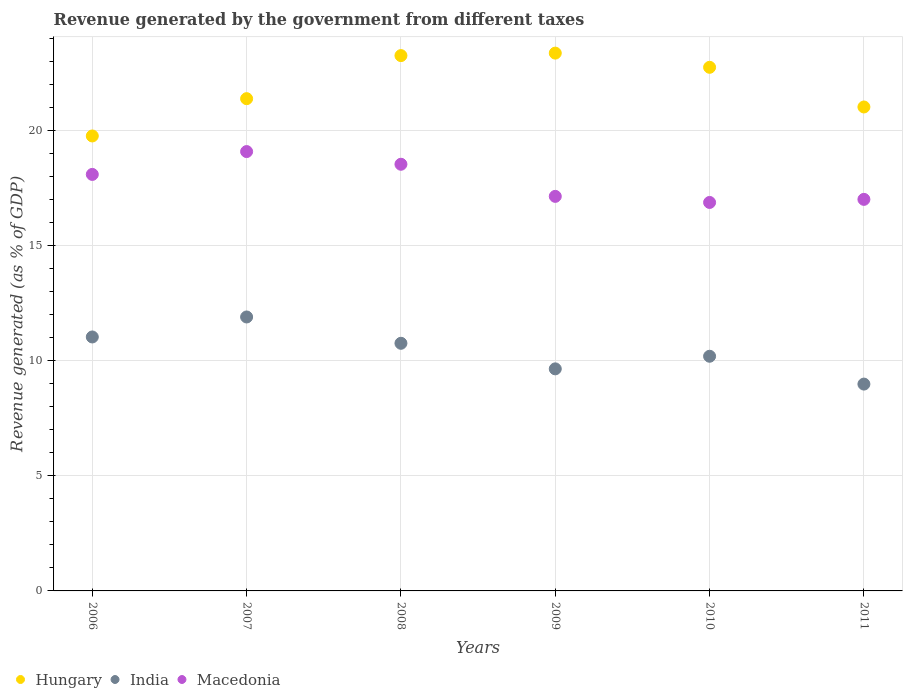How many different coloured dotlines are there?
Ensure brevity in your answer.  3. Is the number of dotlines equal to the number of legend labels?
Your answer should be very brief. Yes. What is the revenue generated by the government in Hungary in 2009?
Offer a very short reply. 23.35. Across all years, what is the maximum revenue generated by the government in Macedonia?
Provide a succinct answer. 19.07. Across all years, what is the minimum revenue generated by the government in Macedonia?
Ensure brevity in your answer.  16.87. What is the total revenue generated by the government in Macedonia in the graph?
Ensure brevity in your answer.  106.68. What is the difference between the revenue generated by the government in India in 2007 and that in 2011?
Provide a short and direct response. 2.91. What is the difference between the revenue generated by the government in Macedonia in 2011 and the revenue generated by the government in India in 2010?
Give a very brief answer. 6.81. What is the average revenue generated by the government in Hungary per year?
Provide a short and direct response. 21.91. In the year 2007, what is the difference between the revenue generated by the government in India and revenue generated by the government in Macedonia?
Ensure brevity in your answer.  -7.18. In how many years, is the revenue generated by the government in Macedonia greater than 15 %?
Provide a succinct answer. 6. What is the ratio of the revenue generated by the government in Hungary in 2010 to that in 2011?
Provide a short and direct response. 1.08. What is the difference between the highest and the second highest revenue generated by the government in Hungary?
Your answer should be compact. 0.11. What is the difference between the highest and the lowest revenue generated by the government in Hungary?
Your answer should be compact. 3.6. In how many years, is the revenue generated by the government in Macedonia greater than the average revenue generated by the government in Macedonia taken over all years?
Your response must be concise. 3. Is the sum of the revenue generated by the government in India in 2006 and 2010 greater than the maximum revenue generated by the government in Hungary across all years?
Your response must be concise. No. Does the revenue generated by the government in India monotonically increase over the years?
Offer a terse response. No. Is the revenue generated by the government in Hungary strictly less than the revenue generated by the government in India over the years?
Offer a very short reply. No. How many dotlines are there?
Offer a very short reply. 3. How many years are there in the graph?
Your answer should be compact. 6. Are the values on the major ticks of Y-axis written in scientific E-notation?
Offer a terse response. No. Does the graph contain any zero values?
Keep it short and to the point. No. How many legend labels are there?
Ensure brevity in your answer.  3. What is the title of the graph?
Keep it short and to the point. Revenue generated by the government from different taxes. Does "Cameroon" appear as one of the legend labels in the graph?
Offer a terse response. No. What is the label or title of the X-axis?
Your response must be concise. Years. What is the label or title of the Y-axis?
Offer a terse response. Revenue generated (as % of GDP). What is the Revenue generated (as % of GDP) in Hungary in 2006?
Make the answer very short. 19.75. What is the Revenue generated (as % of GDP) in India in 2006?
Ensure brevity in your answer.  11.03. What is the Revenue generated (as % of GDP) in Macedonia in 2006?
Your response must be concise. 18.08. What is the Revenue generated (as % of GDP) in Hungary in 2007?
Your response must be concise. 21.37. What is the Revenue generated (as % of GDP) in India in 2007?
Offer a very short reply. 11.89. What is the Revenue generated (as % of GDP) in Macedonia in 2007?
Give a very brief answer. 19.07. What is the Revenue generated (as % of GDP) of Hungary in 2008?
Your response must be concise. 23.24. What is the Revenue generated (as % of GDP) of India in 2008?
Your answer should be compact. 10.75. What is the Revenue generated (as % of GDP) of Macedonia in 2008?
Provide a short and direct response. 18.52. What is the Revenue generated (as % of GDP) in Hungary in 2009?
Provide a short and direct response. 23.35. What is the Revenue generated (as % of GDP) in India in 2009?
Offer a terse response. 9.64. What is the Revenue generated (as % of GDP) in Macedonia in 2009?
Your answer should be compact. 17.13. What is the Revenue generated (as % of GDP) of Hungary in 2010?
Give a very brief answer. 22.73. What is the Revenue generated (as % of GDP) of India in 2010?
Give a very brief answer. 10.19. What is the Revenue generated (as % of GDP) in Macedonia in 2010?
Offer a terse response. 16.87. What is the Revenue generated (as % of GDP) in Hungary in 2011?
Ensure brevity in your answer.  21.01. What is the Revenue generated (as % of GDP) in India in 2011?
Ensure brevity in your answer.  8.98. What is the Revenue generated (as % of GDP) of Macedonia in 2011?
Make the answer very short. 17. Across all years, what is the maximum Revenue generated (as % of GDP) in Hungary?
Make the answer very short. 23.35. Across all years, what is the maximum Revenue generated (as % of GDP) in India?
Keep it short and to the point. 11.89. Across all years, what is the maximum Revenue generated (as % of GDP) in Macedonia?
Your answer should be compact. 19.07. Across all years, what is the minimum Revenue generated (as % of GDP) in Hungary?
Offer a terse response. 19.75. Across all years, what is the minimum Revenue generated (as % of GDP) of India?
Offer a very short reply. 8.98. Across all years, what is the minimum Revenue generated (as % of GDP) of Macedonia?
Your response must be concise. 16.87. What is the total Revenue generated (as % of GDP) in Hungary in the graph?
Your answer should be compact. 131.46. What is the total Revenue generated (as % of GDP) in India in the graph?
Your response must be concise. 62.48. What is the total Revenue generated (as % of GDP) of Macedonia in the graph?
Make the answer very short. 106.68. What is the difference between the Revenue generated (as % of GDP) in Hungary in 2006 and that in 2007?
Give a very brief answer. -1.62. What is the difference between the Revenue generated (as % of GDP) in India in 2006 and that in 2007?
Keep it short and to the point. -0.87. What is the difference between the Revenue generated (as % of GDP) in Macedonia in 2006 and that in 2007?
Give a very brief answer. -0.99. What is the difference between the Revenue generated (as % of GDP) of Hungary in 2006 and that in 2008?
Your answer should be very brief. -3.49. What is the difference between the Revenue generated (as % of GDP) of India in 2006 and that in 2008?
Provide a succinct answer. 0.27. What is the difference between the Revenue generated (as % of GDP) of Macedonia in 2006 and that in 2008?
Your response must be concise. -0.44. What is the difference between the Revenue generated (as % of GDP) in Hungary in 2006 and that in 2009?
Offer a terse response. -3.6. What is the difference between the Revenue generated (as % of GDP) in India in 2006 and that in 2009?
Your answer should be compact. 1.38. What is the difference between the Revenue generated (as % of GDP) of Macedonia in 2006 and that in 2009?
Give a very brief answer. 0.95. What is the difference between the Revenue generated (as % of GDP) in Hungary in 2006 and that in 2010?
Keep it short and to the point. -2.98. What is the difference between the Revenue generated (as % of GDP) of India in 2006 and that in 2010?
Your response must be concise. 0.84. What is the difference between the Revenue generated (as % of GDP) of Macedonia in 2006 and that in 2010?
Provide a short and direct response. 1.22. What is the difference between the Revenue generated (as % of GDP) of Hungary in 2006 and that in 2011?
Give a very brief answer. -1.26. What is the difference between the Revenue generated (as % of GDP) of India in 2006 and that in 2011?
Your answer should be compact. 2.05. What is the difference between the Revenue generated (as % of GDP) in Macedonia in 2006 and that in 2011?
Make the answer very short. 1.08. What is the difference between the Revenue generated (as % of GDP) of Hungary in 2007 and that in 2008?
Your answer should be very brief. -1.87. What is the difference between the Revenue generated (as % of GDP) in India in 2007 and that in 2008?
Give a very brief answer. 1.14. What is the difference between the Revenue generated (as % of GDP) in Macedonia in 2007 and that in 2008?
Your answer should be very brief. 0.55. What is the difference between the Revenue generated (as % of GDP) of Hungary in 2007 and that in 2009?
Offer a terse response. -1.98. What is the difference between the Revenue generated (as % of GDP) of India in 2007 and that in 2009?
Your response must be concise. 2.25. What is the difference between the Revenue generated (as % of GDP) of Macedonia in 2007 and that in 2009?
Offer a very short reply. 1.95. What is the difference between the Revenue generated (as % of GDP) in Hungary in 2007 and that in 2010?
Give a very brief answer. -1.36. What is the difference between the Revenue generated (as % of GDP) in India in 2007 and that in 2010?
Your response must be concise. 1.71. What is the difference between the Revenue generated (as % of GDP) of Macedonia in 2007 and that in 2010?
Offer a very short reply. 2.21. What is the difference between the Revenue generated (as % of GDP) in Hungary in 2007 and that in 2011?
Your answer should be very brief. 0.36. What is the difference between the Revenue generated (as % of GDP) in India in 2007 and that in 2011?
Your answer should be very brief. 2.91. What is the difference between the Revenue generated (as % of GDP) in Macedonia in 2007 and that in 2011?
Provide a short and direct response. 2.08. What is the difference between the Revenue generated (as % of GDP) of Hungary in 2008 and that in 2009?
Your answer should be very brief. -0.11. What is the difference between the Revenue generated (as % of GDP) in India in 2008 and that in 2009?
Offer a terse response. 1.11. What is the difference between the Revenue generated (as % of GDP) of Macedonia in 2008 and that in 2009?
Your response must be concise. 1.39. What is the difference between the Revenue generated (as % of GDP) of Hungary in 2008 and that in 2010?
Provide a short and direct response. 0.51. What is the difference between the Revenue generated (as % of GDP) of India in 2008 and that in 2010?
Offer a very short reply. 0.56. What is the difference between the Revenue generated (as % of GDP) in Macedonia in 2008 and that in 2010?
Ensure brevity in your answer.  1.66. What is the difference between the Revenue generated (as % of GDP) of Hungary in 2008 and that in 2011?
Your response must be concise. 2.23. What is the difference between the Revenue generated (as % of GDP) of India in 2008 and that in 2011?
Your answer should be compact. 1.77. What is the difference between the Revenue generated (as % of GDP) in Macedonia in 2008 and that in 2011?
Your response must be concise. 1.52. What is the difference between the Revenue generated (as % of GDP) of Hungary in 2009 and that in 2010?
Offer a terse response. 0.62. What is the difference between the Revenue generated (as % of GDP) of India in 2009 and that in 2010?
Ensure brevity in your answer.  -0.55. What is the difference between the Revenue generated (as % of GDP) in Macedonia in 2009 and that in 2010?
Keep it short and to the point. 0.26. What is the difference between the Revenue generated (as % of GDP) in Hungary in 2009 and that in 2011?
Give a very brief answer. 2.34. What is the difference between the Revenue generated (as % of GDP) in India in 2009 and that in 2011?
Make the answer very short. 0.66. What is the difference between the Revenue generated (as % of GDP) of Macedonia in 2009 and that in 2011?
Offer a terse response. 0.13. What is the difference between the Revenue generated (as % of GDP) of Hungary in 2010 and that in 2011?
Give a very brief answer. 1.72. What is the difference between the Revenue generated (as % of GDP) of India in 2010 and that in 2011?
Give a very brief answer. 1.21. What is the difference between the Revenue generated (as % of GDP) in Macedonia in 2010 and that in 2011?
Give a very brief answer. -0.13. What is the difference between the Revenue generated (as % of GDP) in Hungary in 2006 and the Revenue generated (as % of GDP) in India in 2007?
Offer a terse response. 7.86. What is the difference between the Revenue generated (as % of GDP) of Hungary in 2006 and the Revenue generated (as % of GDP) of Macedonia in 2007?
Ensure brevity in your answer.  0.68. What is the difference between the Revenue generated (as % of GDP) of India in 2006 and the Revenue generated (as % of GDP) of Macedonia in 2007?
Provide a succinct answer. -8.05. What is the difference between the Revenue generated (as % of GDP) in Hungary in 2006 and the Revenue generated (as % of GDP) in India in 2008?
Your response must be concise. 9. What is the difference between the Revenue generated (as % of GDP) in Hungary in 2006 and the Revenue generated (as % of GDP) in Macedonia in 2008?
Your response must be concise. 1.23. What is the difference between the Revenue generated (as % of GDP) in India in 2006 and the Revenue generated (as % of GDP) in Macedonia in 2008?
Provide a succinct answer. -7.5. What is the difference between the Revenue generated (as % of GDP) in Hungary in 2006 and the Revenue generated (as % of GDP) in India in 2009?
Offer a terse response. 10.11. What is the difference between the Revenue generated (as % of GDP) in Hungary in 2006 and the Revenue generated (as % of GDP) in Macedonia in 2009?
Provide a succinct answer. 2.62. What is the difference between the Revenue generated (as % of GDP) in India in 2006 and the Revenue generated (as % of GDP) in Macedonia in 2009?
Your response must be concise. -6.1. What is the difference between the Revenue generated (as % of GDP) in Hungary in 2006 and the Revenue generated (as % of GDP) in India in 2010?
Provide a succinct answer. 9.56. What is the difference between the Revenue generated (as % of GDP) of Hungary in 2006 and the Revenue generated (as % of GDP) of Macedonia in 2010?
Keep it short and to the point. 2.89. What is the difference between the Revenue generated (as % of GDP) in India in 2006 and the Revenue generated (as % of GDP) in Macedonia in 2010?
Give a very brief answer. -5.84. What is the difference between the Revenue generated (as % of GDP) of Hungary in 2006 and the Revenue generated (as % of GDP) of India in 2011?
Ensure brevity in your answer.  10.77. What is the difference between the Revenue generated (as % of GDP) of Hungary in 2006 and the Revenue generated (as % of GDP) of Macedonia in 2011?
Offer a very short reply. 2.75. What is the difference between the Revenue generated (as % of GDP) of India in 2006 and the Revenue generated (as % of GDP) of Macedonia in 2011?
Offer a very short reply. -5.97. What is the difference between the Revenue generated (as % of GDP) of Hungary in 2007 and the Revenue generated (as % of GDP) of India in 2008?
Ensure brevity in your answer.  10.62. What is the difference between the Revenue generated (as % of GDP) in Hungary in 2007 and the Revenue generated (as % of GDP) in Macedonia in 2008?
Provide a succinct answer. 2.85. What is the difference between the Revenue generated (as % of GDP) of India in 2007 and the Revenue generated (as % of GDP) of Macedonia in 2008?
Provide a short and direct response. -6.63. What is the difference between the Revenue generated (as % of GDP) in Hungary in 2007 and the Revenue generated (as % of GDP) in India in 2009?
Provide a short and direct response. 11.73. What is the difference between the Revenue generated (as % of GDP) of Hungary in 2007 and the Revenue generated (as % of GDP) of Macedonia in 2009?
Keep it short and to the point. 4.24. What is the difference between the Revenue generated (as % of GDP) of India in 2007 and the Revenue generated (as % of GDP) of Macedonia in 2009?
Provide a short and direct response. -5.24. What is the difference between the Revenue generated (as % of GDP) of Hungary in 2007 and the Revenue generated (as % of GDP) of India in 2010?
Offer a very short reply. 11.18. What is the difference between the Revenue generated (as % of GDP) of Hungary in 2007 and the Revenue generated (as % of GDP) of Macedonia in 2010?
Make the answer very short. 4.51. What is the difference between the Revenue generated (as % of GDP) in India in 2007 and the Revenue generated (as % of GDP) in Macedonia in 2010?
Ensure brevity in your answer.  -4.97. What is the difference between the Revenue generated (as % of GDP) in Hungary in 2007 and the Revenue generated (as % of GDP) in India in 2011?
Your answer should be compact. 12.39. What is the difference between the Revenue generated (as % of GDP) in Hungary in 2007 and the Revenue generated (as % of GDP) in Macedonia in 2011?
Offer a terse response. 4.37. What is the difference between the Revenue generated (as % of GDP) in India in 2007 and the Revenue generated (as % of GDP) in Macedonia in 2011?
Your answer should be compact. -5.11. What is the difference between the Revenue generated (as % of GDP) in Hungary in 2008 and the Revenue generated (as % of GDP) in India in 2009?
Your answer should be very brief. 13.6. What is the difference between the Revenue generated (as % of GDP) in Hungary in 2008 and the Revenue generated (as % of GDP) in Macedonia in 2009?
Offer a very short reply. 6.11. What is the difference between the Revenue generated (as % of GDP) in India in 2008 and the Revenue generated (as % of GDP) in Macedonia in 2009?
Keep it short and to the point. -6.38. What is the difference between the Revenue generated (as % of GDP) in Hungary in 2008 and the Revenue generated (as % of GDP) in India in 2010?
Make the answer very short. 13.05. What is the difference between the Revenue generated (as % of GDP) of Hungary in 2008 and the Revenue generated (as % of GDP) of Macedonia in 2010?
Keep it short and to the point. 6.38. What is the difference between the Revenue generated (as % of GDP) of India in 2008 and the Revenue generated (as % of GDP) of Macedonia in 2010?
Make the answer very short. -6.11. What is the difference between the Revenue generated (as % of GDP) in Hungary in 2008 and the Revenue generated (as % of GDP) in India in 2011?
Provide a succinct answer. 14.26. What is the difference between the Revenue generated (as % of GDP) of Hungary in 2008 and the Revenue generated (as % of GDP) of Macedonia in 2011?
Your response must be concise. 6.24. What is the difference between the Revenue generated (as % of GDP) of India in 2008 and the Revenue generated (as % of GDP) of Macedonia in 2011?
Make the answer very short. -6.25. What is the difference between the Revenue generated (as % of GDP) in Hungary in 2009 and the Revenue generated (as % of GDP) in India in 2010?
Provide a short and direct response. 13.16. What is the difference between the Revenue generated (as % of GDP) in Hungary in 2009 and the Revenue generated (as % of GDP) in Macedonia in 2010?
Give a very brief answer. 6.48. What is the difference between the Revenue generated (as % of GDP) in India in 2009 and the Revenue generated (as % of GDP) in Macedonia in 2010?
Provide a succinct answer. -7.22. What is the difference between the Revenue generated (as % of GDP) of Hungary in 2009 and the Revenue generated (as % of GDP) of India in 2011?
Ensure brevity in your answer.  14.37. What is the difference between the Revenue generated (as % of GDP) of Hungary in 2009 and the Revenue generated (as % of GDP) of Macedonia in 2011?
Offer a very short reply. 6.35. What is the difference between the Revenue generated (as % of GDP) in India in 2009 and the Revenue generated (as % of GDP) in Macedonia in 2011?
Your response must be concise. -7.36. What is the difference between the Revenue generated (as % of GDP) of Hungary in 2010 and the Revenue generated (as % of GDP) of India in 2011?
Provide a succinct answer. 13.75. What is the difference between the Revenue generated (as % of GDP) in Hungary in 2010 and the Revenue generated (as % of GDP) in Macedonia in 2011?
Provide a succinct answer. 5.73. What is the difference between the Revenue generated (as % of GDP) in India in 2010 and the Revenue generated (as % of GDP) in Macedonia in 2011?
Your answer should be compact. -6.81. What is the average Revenue generated (as % of GDP) in Hungary per year?
Your answer should be compact. 21.91. What is the average Revenue generated (as % of GDP) of India per year?
Your response must be concise. 10.41. What is the average Revenue generated (as % of GDP) of Macedonia per year?
Provide a succinct answer. 17.78. In the year 2006, what is the difference between the Revenue generated (as % of GDP) of Hungary and Revenue generated (as % of GDP) of India?
Make the answer very short. 8.73. In the year 2006, what is the difference between the Revenue generated (as % of GDP) in Hungary and Revenue generated (as % of GDP) in Macedonia?
Make the answer very short. 1.67. In the year 2006, what is the difference between the Revenue generated (as % of GDP) of India and Revenue generated (as % of GDP) of Macedonia?
Provide a succinct answer. -7.06. In the year 2007, what is the difference between the Revenue generated (as % of GDP) of Hungary and Revenue generated (as % of GDP) of India?
Offer a very short reply. 9.48. In the year 2007, what is the difference between the Revenue generated (as % of GDP) of Hungary and Revenue generated (as % of GDP) of Macedonia?
Your answer should be very brief. 2.3. In the year 2007, what is the difference between the Revenue generated (as % of GDP) in India and Revenue generated (as % of GDP) in Macedonia?
Offer a very short reply. -7.18. In the year 2008, what is the difference between the Revenue generated (as % of GDP) of Hungary and Revenue generated (as % of GDP) of India?
Keep it short and to the point. 12.49. In the year 2008, what is the difference between the Revenue generated (as % of GDP) of Hungary and Revenue generated (as % of GDP) of Macedonia?
Provide a short and direct response. 4.72. In the year 2008, what is the difference between the Revenue generated (as % of GDP) in India and Revenue generated (as % of GDP) in Macedonia?
Give a very brief answer. -7.77. In the year 2009, what is the difference between the Revenue generated (as % of GDP) in Hungary and Revenue generated (as % of GDP) in India?
Offer a very short reply. 13.71. In the year 2009, what is the difference between the Revenue generated (as % of GDP) in Hungary and Revenue generated (as % of GDP) in Macedonia?
Offer a very short reply. 6.22. In the year 2009, what is the difference between the Revenue generated (as % of GDP) in India and Revenue generated (as % of GDP) in Macedonia?
Your answer should be compact. -7.49. In the year 2010, what is the difference between the Revenue generated (as % of GDP) in Hungary and Revenue generated (as % of GDP) in India?
Keep it short and to the point. 12.54. In the year 2010, what is the difference between the Revenue generated (as % of GDP) of Hungary and Revenue generated (as % of GDP) of Macedonia?
Offer a terse response. 5.87. In the year 2010, what is the difference between the Revenue generated (as % of GDP) of India and Revenue generated (as % of GDP) of Macedonia?
Offer a very short reply. -6.68. In the year 2011, what is the difference between the Revenue generated (as % of GDP) in Hungary and Revenue generated (as % of GDP) in India?
Make the answer very short. 12.03. In the year 2011, what is the difference between the Revenue generated (as % of GDP) of Hungary and Revenue generated (as % of GDP) of Macedonia?
Ensure brevity in your answer.  4.01. In the year 2011, what is the difference between the Revenue generated (as % of GDP) of India and Revenue generated (as % of GDP) of Macedonia?
Offer a very short reply. -8.02. What is the ratio of the Revenue generated (as % of GDP) of Hungary in 2006 to that in 2007?
Your answer should be compact. 0.92. What is the ratio of the Revenue generated (as % of GDP) in India in 2006 to that in 2007?
Offer a very short reply. 0.93. What is the ratio of the Revenue generated (as % of GDP) in Macedonia in 2006 to that in 2007?
Give a very brief answer. 0.95. What is the ratio of the Revenue generated (as % of GDP) of Hungary in 2006 to that in 2008?
Make the answer very short. 0.85. What is the ratio of the Revenue generated (as % of GDP) of India in 2006 to that in 2008?
Ensure brevity in your answer.  1.03. What is the ratio of the Revenue generated (as % of GDP) of Macedonia in 2006 to that in 2008?
Ensure brevity in your answer.  0.98. What is the ratio of the Revenue generated (as % of GDP) in Hungary in 2006 to that in 2009?
Your answer should be very brief. 0.85. What is the ratio of the Revenue generated (as % of GDP) of India in 2006 to that in 2009?
Your response must be concise. 1.14. What is the ratio of the Revenue generated (as % of GDP) of Macedonia in 2006 to that in 2009?
Your response must be concise. 1.06. What is the ratio of the Revenue generated (as % of GDP) of Hungary in 2006 to that in 2010?
Give a very brief answer. 0.87. What is the ratio of the Revenue generated (as % of GDP) in India in 2006 to that in 2010?
Provide a succinct answer. 1.08. What is the ratio of the Revenue generated (as % of GDP) in Macedonia in 2006 to that in 2010?
Provide a succinct answer. 1.07. What is the ratio of the Revenue generated (as % of GDP) in Hungary in 2006 to that in 2011?
Your response must be concise. 0.94. What is the ratio of the Revenue generated (as % of GDP) of India in 2006 to that in 2011?
Offer a very short reply. 1.23. What is the ratio of the Revenue generated (as % of GDP) of Macedonia in 2006 to that in 2011?
Provide a succinct answer. 1.06. What is the ratio of the Revenue generated (as % of GDP) of Hungary in 2007 to that in 2008?
Provide a short and direct response. 0.92. What is the ratio of the Revenue generated (as % of GDP) in India in 2007 to that in 2008?
Offer a very short reply. 1.11. What is the ratio of the Revenue generated (as % of GDP) of Macedonia in 2007 to that in 2008?
Ensure brevity in your answer.  1.03. What is the ratio of the Revenue generated (as % of GDP) in Hungary in 2007 to that in 2009?
Provide a short and direct response. 0.92. What is the ratio of the Revenue generated (as % of GDP) in India in 2007 to that in 2009?
Keep it short and to the point. 1.23. What is the ratio of the Revenue generated (as % of GDP) in Macedonia in 2007 to that in 2009?
Ensure brevity in your answer.  1.11. What is the ratio of the Revenue generated (as % of GDP) in Hungary in 2007 to that in 2010?
Ensure brevity in your answer.  0.94. What is the ratio of the Revenue generated (as % of GDP) of India in 2007 to that in 2010?
Make the answer very short. 1.17. What is the ratio of the Revenue generated (as % of GDP) of Macedonia in 2007 to that in 2010?
Keep it short and to the point. 1.13. What is the ratio of the Revenue generated (as % of GDP) in Hungary in 2007 to that in 2011?
Offer a very short reply. 1.02. What is the ratio of the Revenue generated (as % of GDP) of India in 2007 to that in 2011?
Provide a short and direct response. 1.32. What is the ratio of the Revenue generated (as % of GDP) of Macedonia in 2007 to that in 2011?
Offer a very short reply. 1.12. What is the ratio of the Revenue generated (as % of GDP) in Hungary in 2008 to that in 2009?
Keep it short and to the point. 1. What is the ratio of the Revenue generated (as % of GDP) of India in 2008 to that in 2009?
Give a very brief answer. 1.12. What is the ratio of the Revenue generated (as % of GDP) of Macedonia in 2008 to that in 2009?
Keep it short and to the point. 1.08. What is the ratio of the Revenue generated (as % of GDP) of Hungary in 2008 to that in 2010?
Give a very brief answer. 1.02. What is the ratio of the Revenue generated (as % of GDP) in India in 2008 to that in 2010?
Your answer should be very brief. 1.06. What is the ratio of the Revenue generated (as % of GDP) in Macedonia in 2008 to that in 2010?
Offer a very short reply. 1.1. What is the ratio of the Revenue generated (as % of GDP) of Hungary in 2008 to that in 2011?
Ensure brevity in your answer.  1.11. What is the ratio of the Revenue generated (as % of GDP) in India in 2008 to that in 2011?
Ensure brevity in your answer.  1.2. What is the ratio of the Revenue generated (as % of GDP) of Macedonia in 2008 to that in 2011?
Provide a succinct answer. 1.09. What is the ratio of the Revenue generated (as % of GDP) in Hungary in 2009 to that in 2010?
Keep it short and to the point. 1.03. What is the ratio of the Revenue generated (as % of GDP) of India in 2009 to that in 2010?
Make the answer very short. 0.95. What is the ratio of the Revenue generated (as % of GDP) of Macedonia in 2009 to that in 2010?
Offer a very short reply. 1.02. What is the ratio of the Revenue generated (as % of GDP) in Hungary in 2009 to that in 2011?
Ensure brevity in your answer.  1.11. What is the ratio of the Revenue generated (as % of GDP) of India in 2009 to that in 2011?
Offer a terse response. 1.07. What is the ratio of the Revenue generated (as % of GDP) of Macedonia in 2009 to that in 2011?
Your answer should be very brief. 1.01. What is the ratio of the Revenue generated (as % of GDP) of Hungary in 2010 to that in 2011?
Offer a very short reply. 1.08. What is the ratio of the Revenue generated (as % of GDP) of India in 2010 to that in 2011?
Provide a succinct answer. 1.13. What is the difference between the highest and the second highest Revenue generated (as % of GDP) in Hungary?
Your answer should be compact. 0.11. What is the difference between the highest and the second highest Revenue generated (as % of GDP) of India?
Ensure brevity in your answer.  0.87. What is the difference between the highest and the second highest Revenue generated (as % of GDP) of Macedonia?
Your answer should be very brief. 0.55. What is the difference between the highest and the lowest Revenue generated (as % of GDP) in Hungary?
Make the answer very short. 3.6. What is the difference between the highest and the lowest Revenue generated (as % of GDP) of India?
Ensure brevity in your answer.  2.91. What is the difference between the highest and the lowest Revenue generated (as % of GDP) in Macedonia?
Provide a short and direct response. 2.21. 